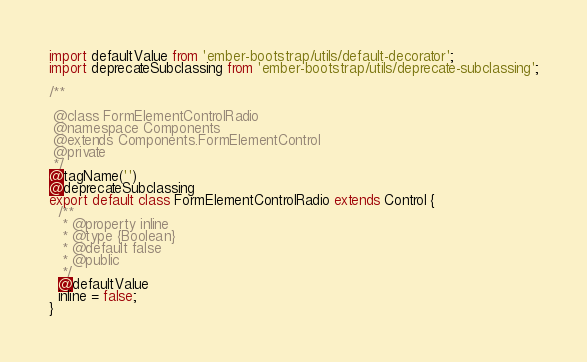<code> <loc_0><loc_0><loc_500><loc_500><_JavaScript_>import defaultValue from 'ember-bootstrap/utils/default-decorator';
import deprecateSubclassing from 'ember-bootstrap/utils/deprecate-subclassing';

/**

 @class FormElementControlRadio
 @namespace Components
 @extends Components.FormElementControl
 @private
 */
@tagName('')
@deprecateSubclassing
export default class FormElementControlRadio extends Control {
  /**
   * @property inline
   * @type {Boolean}
   * @default false
   * @public
   */
  @defaultValue
  inline = false;
}
</code> 